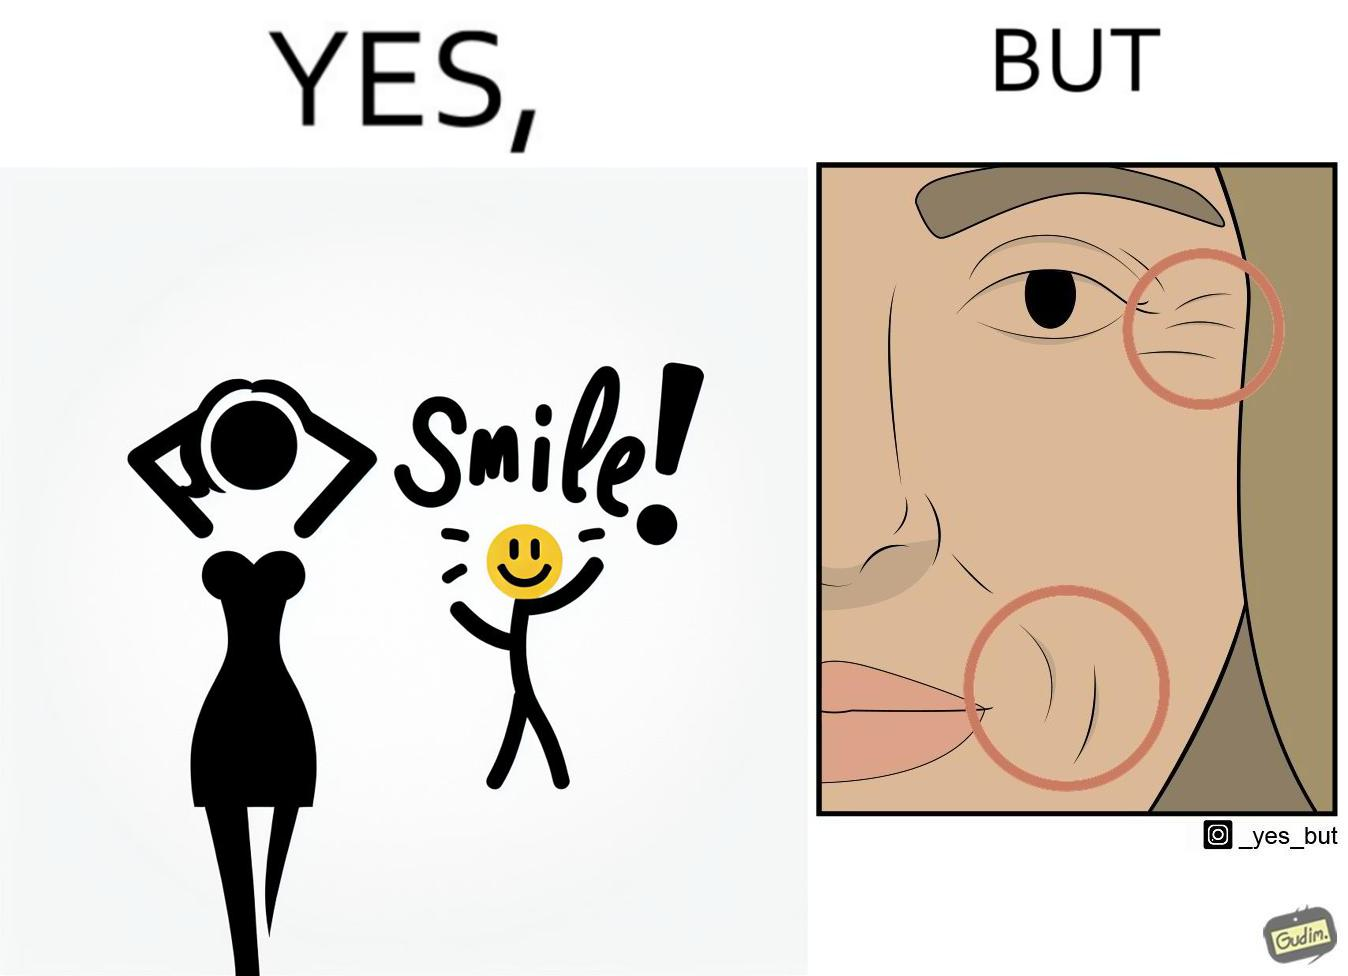Describe what you see in the left and right parts of this image. In the left part of the image: The image shows a woman smiling with a text saying the word "smile!".  There is also a yellow smiley face in the image. In the right part of the image: The image shows a closeup of the face of a woman. The image has red circles around the wrinkles near the woman's lips and eyes highlighting them. 